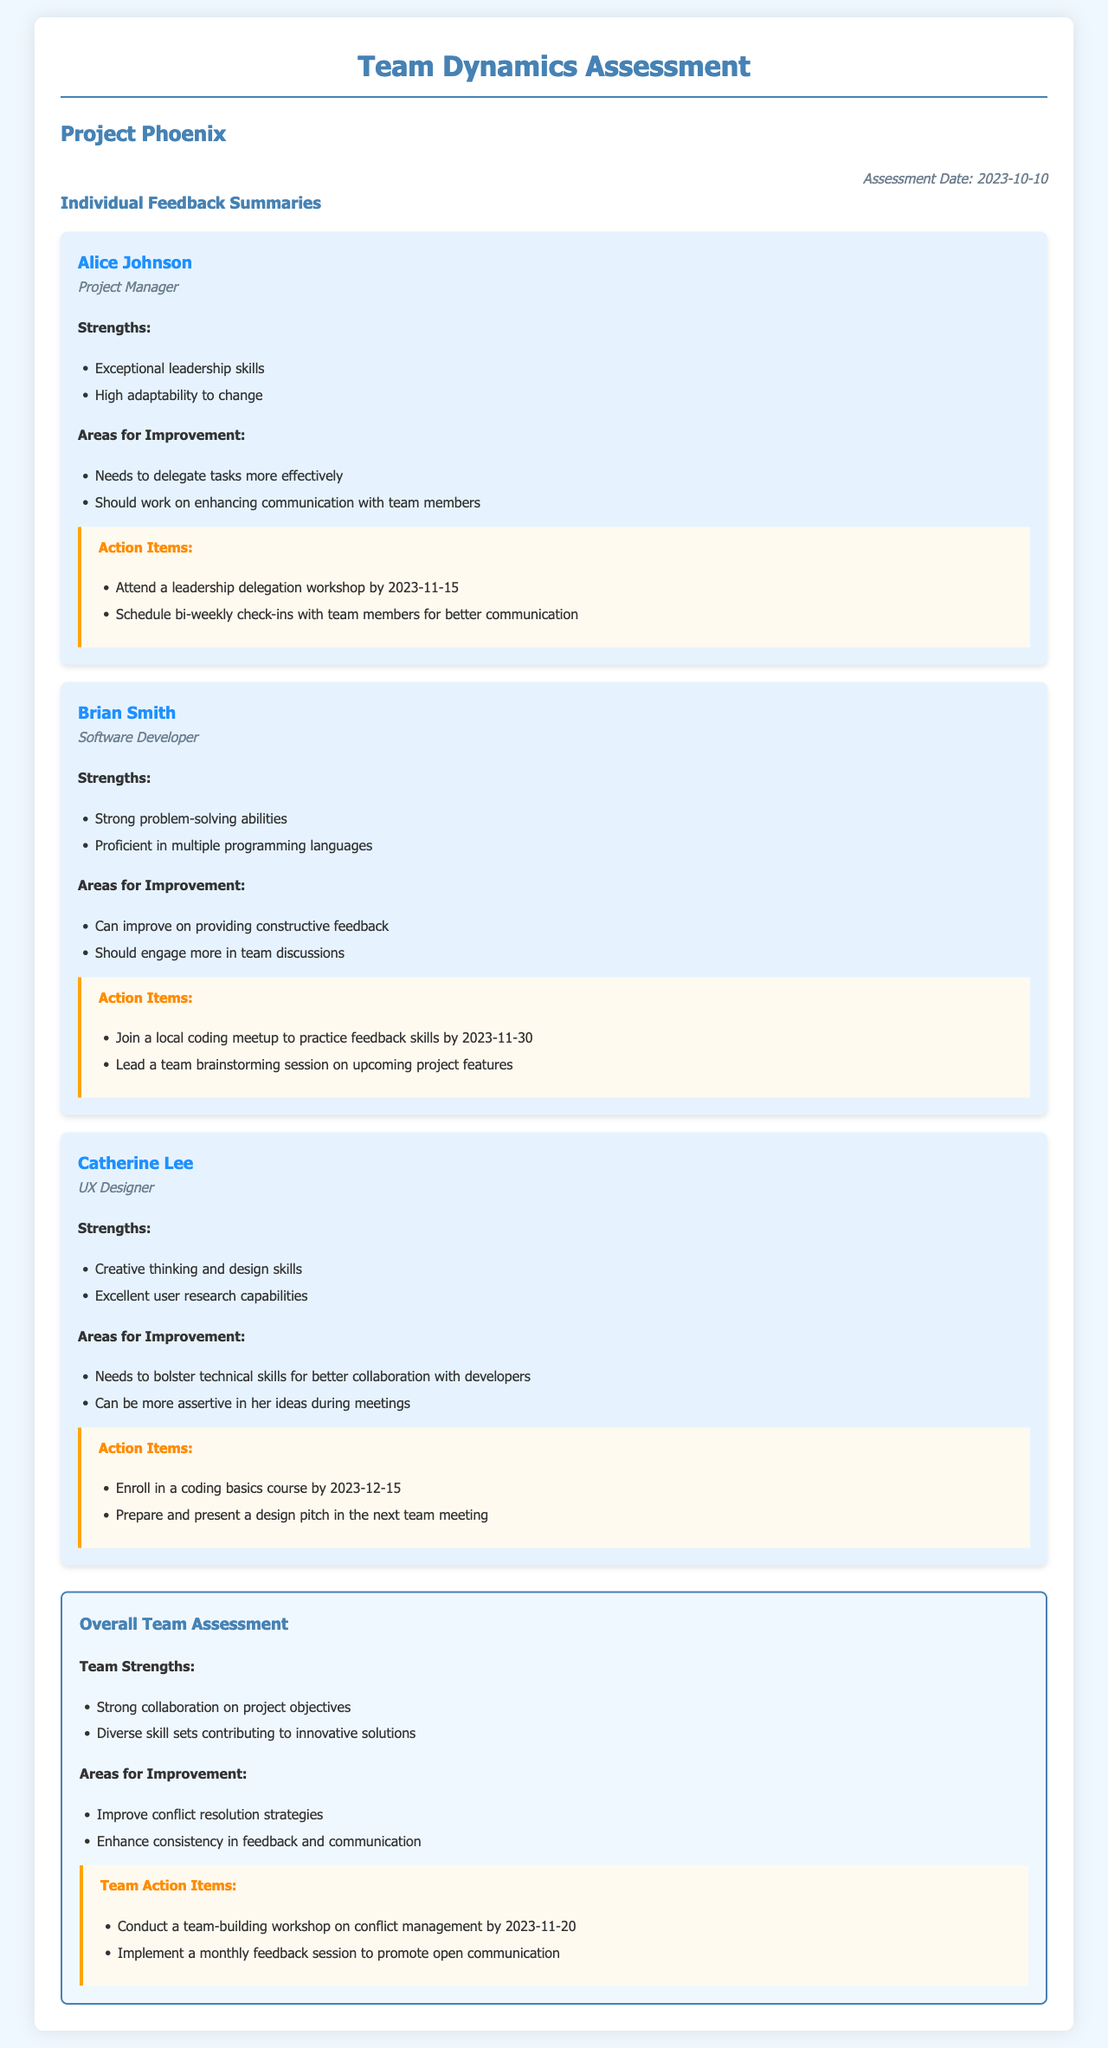What is the assessment date? The assessment date is explicitly mentioned in the date section of the document.
Answer: 2023-10-10 Who is the Project Manager? The member cards list the names and roles of team members, where Alice Johnson is noted as the Project Manager.
Answer: Alice Johnson What workshop should Alice Johnson attend? The action items section for Alice Johnson specifies the workshop she needs to attend to improve her delegation skills.
Answer: Leadership delegation workshop What are Brian Smith's strengths? The strengths for each team member are listed in their respective feedback summaries, and Brian Smith's strengths are highlighted.
Answer: Strong problem-solving abilities, Proficient in multiple programming languages What is one area for improvement for Catherine Lee? The areas for improvement for each member are outlined in their summaries, and one of Catherine Lee's areas needing improvement is noted.
Answer: Needs to bolster technical skills What is a team action item planned for conflict management? The overall assessment section contains action items for the entire team, including specific tasks to enhance team dynamics.
Answer: Conduct a team-building workshop on conflict management Which member should lead a team brainstorming session? The action items for Brian Smith indicate that he should take the initiative in a particular team activity, emphasizing his involvement.
Answer: Lead a team brainstorming session What is one of the team strengths? The overall strengths of the team are mentioned in the overall assessment section, focusing on their collaborative efforts.
Answer: Strong collaboration on project objectives 